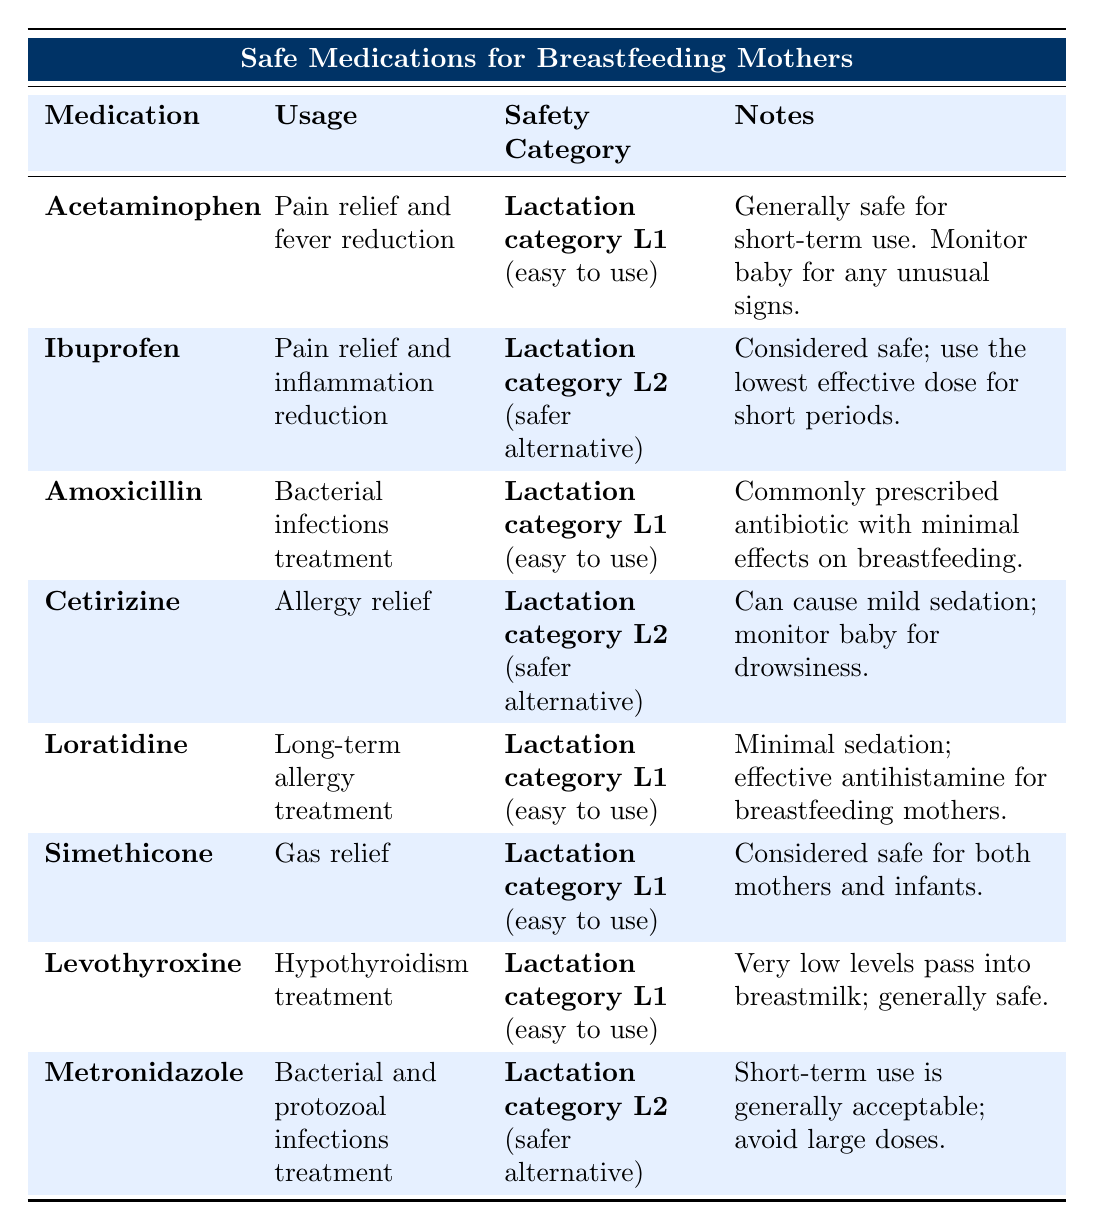What is the usage of Acetaminophen? The table states that Acetaminophen is used for pain relief and fever reduction.
Answer: Pain relief and fever reduction Which medications are categorized as Lactation category L1? The table lists Acetaminophen, Amoxicillin, Loratadine, Simethicone, and Levothyroxine under Lactation category L1.
Answer: Acetaminophen, Amoxicillin, Loratadine, Simethicone, Levothyroxine Is Metronidazole safe for long-term use? The notes for Metronidazole advise against large doses and indicate that short-term use is generally acceptable, suggesting it's not recommended for long-term use.
Answer: No How many medications are considered safer alternatives (Lactation category L2)? The table shows two medications categorized as Lactation category L2: Ibuprofen, Cetirizine, and Metronidazole. That gives us a total of three medications.
Answer: 3 What is the note related to Cetirizine? The note for Cetirizine mentions it can cause mild sedation and advises monitoring the baby for drowsiness.
Answer: Can cause mild sedation; monitor baby for drowsiness Which medication is described as effective for long-term allergy treatment? The table indicates that Loratadine is used for long-term allergy treatment.
Answer: Loratadine What is the difference in safety categories between Ibuprofen and Levothyroxine? Ibuprofen is categorized as Lactation category L2 (safer alternative), while Levothyroxine is categorized as L1 (easy to use). The difference is that Levothyroxine is easier to use.
Answer: Lactation category L2 (Ibuprofen) vs Lactation category L1 (Levothyroxine) If a mother is treating a bacterial infection, which medications can she consider? The table shows Acetaminophen and Amoxicillin as options for treating bacterial infections, with Amoxicillin specifically mentioned for that purpose.
Answer: Amoxicillin (also Acetaminophen for pain relief) How can I monitor side effects if I take Cetirizine as a breastfeeding mother? You should monitor the baby for drowsiness, as the note for Cetirizine suggests it may cause mild sedation.
Answer: Monitor baby for drowsiness Which medication has the least potential to affect breastfeeding according to its usage and safety category? The medication Levothyroxine, categorized as Lactation category L1 and noted for very low levels passing into breastmilk, indicates it has minimal potential to affect breastfeeding.
Answer: Levothyroxine How many medications are primarily for pain relief and have different safety categories? There are two pain relief medications: Acetaminophen (L1) and Ibuprofen (L2), indicating they have different safety categories.
Answer: 2 